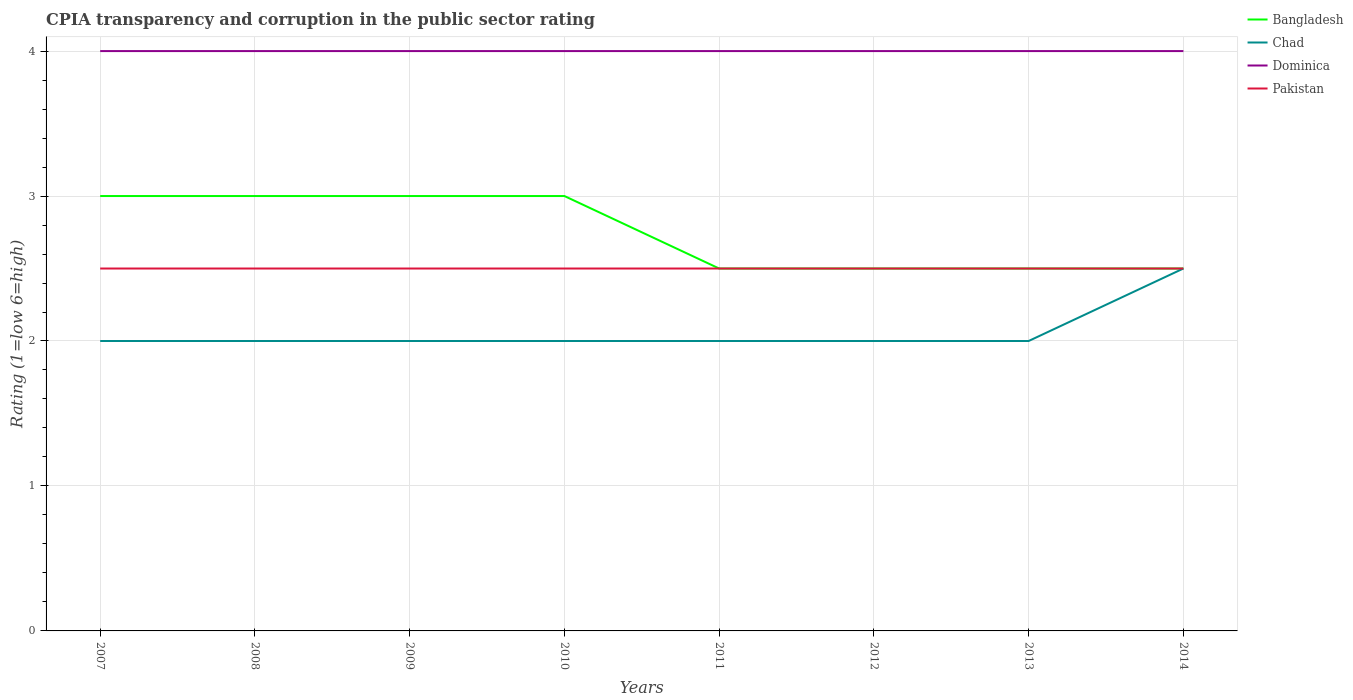How many different coloured lines are there?
Keep it short and to the point. 4. Does the line corresponding to Chad intersect with the line corresponding to Pakistan?
Make the answer very short. Yes. Across all years, what is the maximum CPIA rating in Dominica?
Your answer should be compact. 4. What is the difference between the highest and the lowest CPIA rating in Bangladesh?
Offer a very short reply. 4. Is the CPIA rating in Bangladesh strictly greater than the CPIA rating in Chad over the years?
Your answer should be very brief. No. How many years are there in the graph?
Give a very brief answer. 8. Does the graph contain any zero values?
Give a very brief answer. No. Where does the legend appear in the graph?
Provide a short and direct response. Top right. How many legend labels are there?
Keep it short and to the point. 4. How are the legend labels stacked?
Give a very brief answer. Vertical. What is the title of the graph?
Provide a short and direct response. CPIA transparency and corruption in the public sector rating. Does "Mauritania" appear as one of the legend labels in the graph?
Make the answer very short. No. What is the label or title of the X-axis?
Your response must be concise. Years. What is the label or title of the Y-axis?
Provide a succinct answer. Rating (1=low 6=high). What is the Rating (1=low 6=high) in Pakistan in 2007?
Provide a short and direct response. 2.5. What is the Rating (1=low 6=high) of Pakistan in 2008?
Your answer should be very brief. 2.5. What is the Rating (1=low 6=high) of Bangladesh in 2009?
Give a very brief answer. 3. What is the Rating (1=low 6=high) in Chad in 2009?
Keep it short and to the point. 2. What is the Rating (1=low 6=high) of Bangladesh in 2010?
Keep it short and to the point. 3. What is the Rating (1=low 6=high) in Chad in 2010?
Your answer should be compact. 2. What is the Rating (1=low 6=high) of Dominica in 2010?
Provide a short and direct response. 4. What is the Rating (1=low 6=high) of Pakistan in 2010?
Provide a succinct answer. 2.5. What is the Rating (1=low 6=high) of Chad in 2011?
Make the answer very short. 2. What is the Rating (1=low 6=high) of Dominica in 2011?
Make the answer very short. 4. What is the Rating (1=low 6=high) in Bangladesh in 2012?
Give a very brief answer. 2.5. What is the Rating (1=low 6=high) of Dominica in 2012?
Offer a terse response. 4. What is the Rating (1=low 6=high) in Pakistan in 2012?
Make the answer very short. 2.5. What is the Rating (1=low 6=high) in Bangladesh in 2013?
Your response must be concise. 2.5. What is the Rating (1=low 6=high) in Dominica in 2013?
Keep it short and to the point. 4. What is the Rating (1=low 6=high) in Pakistan in 2014?
Ensure brevity in your answer.  2.5. Across all years, what is the maximum Rating (1=low 6=high) of Bangladesh?
Ensure brevity in your answer.  3. Across all years, what is the maximum Rating (1=low 6=high) in Chad?
Offer a very short reply. 2.5. Across all years, what is the minimum Rating (1=low 6=high) of Bangladesh?
Provide a short and direct response. 2.5. Across all years, what is the minimum Rating (1=low 6=high) in Chad?
Your response must be concise. 2. Across all years, what is the minimum Rating (1=low 6=high) of Dominica?
Provide a short and direct response. 4. What is the total Rating (1=low 6=high) in Bangladesh in the graph?
Your response must be concise. 22. What is the total Rating (1=low 6=high) in Dominica in the graph?
Make the answer very short. 32. What is the difference between the Rating (1=low 6=high) in Chad in 2007 and that in 2008?
Give a very brief answer. 0. What is the difference between the Rating (1=low 6=high) of Dominica in 2007 and that in 2008?
Make the answer very short. 0. What is the difference between the Rating (1=low 6=high) in Pakistan in 2007 and that in 2008?
Offer a very short reply. 0. What is the difference between the Rating (1=low 6=high) in Chad in 2007 and that in 2009?
Ensure brevity in your answer.  0. What is the difference between the Rating (1=low 6=high) of Dominica in 2007 and that in 2009?
Give a very brief answer. 0. What is the difference between the Rating (1=low 6=high) in Pakistan in 2007 and that in 2009?
Keep it short and to the point. 0. What is the difference between the Rating (1=low 6=high) of Chad in 2007 and that in 2010?
Provide a succinct answer. 0. What is the difference between the Rating (1=low 6=high) of Pakistan in 2007 and that in 2010?
Provide a succinct answer. 0. What is the difference between the Rating (1=low 6=high) in Bangladesh in 2007 and that in 2011?
Ensure brevity in your answer.  0.5. What is the difference between the Rating (1=low 6=high) in Chad in 2007 and that in 2012?
Offer a terse response. 0. What is the difference between the Rating (1=low 6=high) of Pakistan in 2007 and that in 2012?
Your response must be concise. 0. What is the difference between the Rating (1=low 6=high) in Bangladesh in 2007 and that in 2013?
Give a very brief answer. 0.5. What is the difference between the Rating (1=low 6=high) in Dominica in 2007 and that in 2013?
Make the answer very short. 0. What is the difference between the Rating (1=low 6=high) of Bangladesh in 2007 and that in 2014?
Give a very brief answer. 0.5. What is the difference between the Rating (1=low 6=high) of Dominica in 2007 and that in 2014?
Your answer should be very brief. 0. What is the difference between the Rating (1=low 6=high) of Bangladesh in 2008 and that in 2009?
Keep it short and to the point. 0. What is the difference between the Rating (1=low 6=high) in Dominica in 2008 and that in 2009?
Ensure brevity in your answer.  0. What is the difference between the Rating (1=low 6=high) in Bangladesh in 2008 and that in 2010?
Provide a short and direct response. 0. What is the difference between the Rating (1=low 6=high) in Chad in 2008 and that in 2010?
Give a very brief answer. 0. What is the difference between the Rating (1=low 6=high) of Dominica in 2008 and that in 2010?
Provide a succinct answer. 0. What is the difference between the Rating (1=low 6=high) of Chad in 2008 and that in 2011?
Provide a succinct answer. 0. What is the difference between the Rating (1=low 6=high) of Pakistan in 2008 and that in 2011?
Ensure brevity in your answer.  0. What is the difference between the Rating (1=low 6=high) of Bangladesh in 2008 and that in 2012?
Your answer should be very brief. 0.5. What is the difference between the Rating (1=low 6=high) of Bangladesh in 2008 and that in 2013?
Provide a succinct answer. 0.5. What is the difference between the Rating (1=low 6=high) in Chad in 2008 and that in 2013?
Ensure brevity in your answer.  0. What is the difference between the Rating (1=low 6=high) in Dominica in 2008 and that in 2014?
Offer a very short reply. 0. What is the difference between the Rating (1=low 6=high) of Chad in 2009 and that in 2010?
Your answer should be compact. 0. What is the difference between the Rating (1=low 6=high) in Dominica in 2009 and that in 2010?
Your response must be concise. 0. What is the difference between the Rating (1=low 6=high) in Bangladesh in 2009 and that in 2011?
Your answer should be very brief. 0.5. What is the difference between the Rating (1=low 6=high) of Chad in 2009 and that in 2011?
Offer a terse response. 0. What is the difference between the Rating (1=low 6=high) in Bangladesh in 2009 and that in 2012?
Provide a short and direct response. 0.5. What is the difference between the Rating (1=low 6=high) in Chad in 2009 and that in 2012?
Provide a short and direct response. 0. What is the difference between the Rating (1=low 6=high) in Dominica in 2009 and that in 2012?
Offer a very short reply. 0. What is the difference between the Rating (1=low 6=high) of Pakistan in 2009 and that in 2012?
Give a very brief answer. 0. What is the difference between the Rating (1=low 6=high) of Bangladesh in 2009 and that in 2013?
Provide a succinct answer. 0.5. What is the difference between the Rating (1=low 6=high) in Chad in 2009 and that in 2013?
Ensure brevity in your answer.  0. What is the difference between the Rating (1=low 6=high) in Dominica in 2009 and that in 2013?
Keep it short and to the point. 0. What is the difference between the Rating (1=low 6=high) in Bangladesh in 2009 and that in 2014?
Ensure brevity in your answer.  0.5. What is the difference between the Rating (1=low 6=high) in Chad in 2009 and that in 2014?
Offer a terse response. -0.5. What is the difference between the Rating (1=low 6=high) of Dominica in 2010 and that in 2011?
Your answer should be very brief. 0. What is the difference between the Rating (1=low 6=high) in Pakistan in 2010 and that in 2011?
Keep it short and to the point. 0. What is the difference between the Rating (1=low 6=high) in Bangladesh in 2010 and that in 2012?
Offer a very short reply. 0.5. What is the difference between the Rating (1=low 6=high) of Chad in 2010 and that in 2012?
Give a very brief answer. 0. What is the difference between the Rating (1=low 6=high) of Pakistan in 2010 and that in 2012?
Provide a succinct answer. 0. What is the difference between the Rating (1=low 6=high) of Chad in 2010 and that in 2013?
Ensure brevity in your answer.  0. What is the difference between the Rating (1=low 6=high) in Dominica in 2010 and that in 2013?
Your answer should be very brief. 0. What is the difference between the Rating (1=low 6=high) in Pakistan in 2010 and that in 2013?
Ensure brevity in your answer.  0. What is the difference between the Rating (1=low 6=high) in Dominica in 2010 and that in 2014?
Give a very brief answer. 0. What is the difference between the Rating (1=low 6=high) in Pakistan in 2011 and that in 2012?
Your answer should be compact. 0. What is the difference between the Rating (1=low 6=high) of Bangladesh in 2011 and that in 2013?
Offer a very short reply. 0. What is the difference between the Rating (1=low 6=high) in Pakistan in 2011 and that in 2013?
Give a very brief answer. 0. What is the difference between the Rating (1=low 6=high) in Pakistan in 2011 and that in 2014?
Your answer should be very brief. 0. What is the difference between the Rating (1=low 6=high) of Bangladesh in 2012 and that in 2013?
Your answer should be compact. 0. What is the difference between the Rating (1=low 6=high) of Chad in 2012 and that in 2013?
Your response must be concise. 0. What is the difference between the Rating (1=low 6=high) of Dominica in 2012 and that in 2013?
Your answer should be compact. 0. What is the difference between the Rating (1=low 6=high) of Dominica in 2012 and that in 2014?
Make the answer very short. 0. What is the difference between the Rating (1=low 6=high) of Pakistan in 2012 and that in 2014?
Keep it short and to the point. 0. What is the difference between the Rating (1=low 6=high) in Bangladesh in 2013 and that in 2014?
Your response must be concise. 0. What is the difference between the Rating (1=low 6=high) in Pakistan in 2013 and that in 2014?
Your response must be concise. 0. What is the difference between the Rating (1=low 6=high) in Bangladesh in 2007 and the Rating (1=low 6=high) in Chad in 2008?
Provide a short and direct response. 1. What is the difference between the Rating (1=low 6=high) of Chad in 2007 and the Rating (1=low 6=high) of Dominica in 2008?
Offer a terse response. -2. What is the difference between the Rating (1=low 6=high) of Dominica in 2007 and the Rating (1=low 6=high) of Pakistan in 2008?
Offer a terse response. 1.5. What is the difference between the Rating (1=low 6=high) in Bangladesh in 2007 and the Rating (1=low 6=high) in Pakistan in 2009?
Provide a short and direct response. 0.5. What is the difference between the Rating (1=low 6=high) of Chad in 2007 and the Rating (1=low 6=high) of Dominica in 2009?
Give a very brief answer. -2. What is the difference between the Rating (1=low 6=high) of Chad in 2007 and the Rating (1=low 6=high) of Pakistan in 2009?
Keep it short and to the point. -0.5. What is the difference between the Rating (1=low 6=high) of Dominica in 2007 and the Rating (1=low 6=high) of Pakistan in 2009?
Offer a terse response. 1.5. What is the difference between the Rating (1=low 6=high) in Dominica in 2007 and the Rating (1=low 6=high) in Pakistan in 2010?
Provide a short and direct response. 1.5. What is the difference between the Rating (1=low 6=high) in Bangladesh in 2007 and the Rating (1=low 6=high) in Pakistan in 2011?
Your answer should be compact. 0.5. What is the difference between the Rating (1=low 6=high) of Chad in 2007 and the Rating (1=low 6=high) of Dominica in 2011?
Your answer should be compact. -2. What is the difference between the Rating (1=low 6=high) in Bangladesh in 2007 and the Rating (1=low 6=high) in Dominica in 2012?
Make the answer very short. -1. What is the difference between the Rating (1=low 6=high) of Bangladesh in 2007 and the Rating (1=low 6=high) of Pakistan in 2012?
Make the answer very short. 0.5. What is the difference between the Rating (1=low 6=high) in Chad in 2007 and the Rating (1=low 6=high) in Pakistan in 2012?
Your answer should be very brief. -0.5. What is the difference between the Rating (1=low 6=high) in Bangladesh in 2007 and the Rating (1=low 6=high) in Pakistan in 2013?
Offer a terse response. 0.5. What is the difference between the Rating (1=low 6=high) of Chad in 2007 and the Rating (1=low 6=high) of Pakistan in 2013?
Provide a short and direct response. -0.5. What is the difference between the Rating (1=low 6=high) in Bangladesh in 2007 and the Rating (1=low 6=high) in Chad in 2014?
Make the answer very short. 0.5. What is the difference between the Rating (1=low 6=high) in Bangladesh in 2007 and the Rating (1=low 6=high) in Dominica in 2014?
Offer a very short reply. -1. What is the difference between the Rating (1=low 6=high) in Bangladesh in 2007 and the Rating (1=low 6=high) in Pakistan in 2014?
Your answer should be compact. 0.5. What is the difference between the Rating (1=low 6=high) of Bangladesh in 2008 and the Rating (1=low 6=high) of Dominica in 2009?
Offer a very short reply. -1. What is the difference between the Rating (1=low 6=high) in Bangladesh in 2008 and the Rating (1=low 6=high) in Pakistan in 2009?
Your answer should be very brief. 0.5. What is the difference between the Rating (1=low 6=high) in Chad in 2008 and the Rating (1=low 6=high) in Pakistan in 2009?
Provide a succinct answer. -0.5. What is the difference between the Rating (1=low 6=high) in Bangladesh in 2008 and the Rating (1=low 6=high) in Dominica in 2010?
Your answer should be compact. -1. What is the difference between the Rating (1=low 6=high) in Chad in 2008 and the Rating (1=low 6=high) in Dominica in 2010?
Make the answer very short. -2. What is the difference between the Rating (1=low 6=high) of Chad in 2008 and the Rating (1=low 6=high) of Pakistan in 2010?
Your answer should be very brief. -0.5. What is the difference between the Rating (1=low 6=high) of Dominica in 2008 and the Rating (1=low 6=high) of Pakistan in 2010?
Make the answer very short. 1.5. What is the difference between the Rating (1=low 6=high) in Bangladesh in 2008 and the Rating (1=low 6=high) in Chad in 2011?
Offer a very short reply. 1. What is the difference between the Rating (1=low 6=high) in Bangladesh in 2008 and the Rating (1=low 6=high) in Dominica in 2011?
Your response must be concise. -1. What is the difference between the Rating (1=low 6=high) in Dominica in 2008 and the Rating (1=low 6=high) in Pakistan in 2011?
Provide a succinct answer. 1.5. What is the difference between the Rating (1=low 6=high) of Bangladesh in 2008 and the Rating (1=low 6=high) of Dominica in 2012?
Give a very brief answer. -1. What is the difference between the Rating (1=low 6=high) in Chad in 2008 and the Rating (1=low 6=high) in Pakistan in 2012?
Make the answer very short. -0.5. What is the difference between the Rating (1=low 6=high) of Dominica in 2008 and the Rating (1=low 6=high) of Pakistan in 2012?
Make the answer very short. 1.5. What is the difference between the Rating (1=low 6=high) of Bangladesh in 2008 and the Rating (1=low 6=high) of Chad in 2013?
Offer a terse response. 1. What is the difference between the Rating (1=low 6=high) of Bangladesh in 2008 and the Rating (1=low 6=high) of Chad in 2014?
Your response must be concise. 0.5. What is the difference between the Rating (1=low 6=high) in Bangladesh in 2008 and the Rating (1=low 6=high) in Dominica in 2014?
Your answer should be very brief. -1. What is the difference between the Rating (1=low 6=high) in Bangladesh in 2008 and the Rating (1=low 6=high) in Pakistan in 2014?
Provide a short and direct response. 0.5. What is the difference between the Rating (1=low 6=high) of Chad in 2008 and the Rating (1=low 6=high) of Dominica in 2014?
Your answer should be very brief. -2. What is the difference between the Rating (1=low 6=high) in Bangladesh in 2009 and the Rating (1=low 6=high) in Chad in 2012?
Ensure brevity in your answer.  1. What is the difference between the Rating (1=low 6=high) of Bangladesh in 2009 and the Rating (1=low 6=high) of Pakistan in 2012?
Your answer should be very brief. 0.5. What is the difference between the Rating (1=low 6=high) in Dominica in 2009 and the Rating (1=low 6=high) in Pakistan in 2012?
Your answer should be compact. 1.5. What is the difference between the Rating (1=low 6=high) of Bangladesh in 2009 and the Rating (1=low 6=high) of Chad in 2013?
Offer a terse response. 1. What is the difference between the Rating (1=low 6=high) in Bangladesh in 2009 and the Rating (1=low 6=high) in Dominica in 2013?
Give a very brief answer. -1. What is the difference between the Rating (1=low 6=high) in Bangladesh in 2009 and the Rating (1=low 6=high) in Pakistan in 2013?
Keep it short and to the point. 0.5. What is the difference between the Rating (1=low 6=high) of Chad in 2009 and the Rating (1=low 6=high) of Dominica in 2013?
Offer a very short reply. -2. What is the difference between the Rating (1=low 6=high) in Chad in 2009 and the Rating (1=low 6=high) in Pakistan in 2013?
Keep it short and to the point. -0.5. What is the difference between the Rating (1=low 6=high) of Dominica in 2009 and the Rating (1=low 6=high) of Pakistan in 2013?
Make the answer very short. 1.5. What is the difference between the Rating (1=low 6=high) of Bangladesh in 2009 and the Rating (1=low 6=high) of Chad in 2014?
Provide a succinct answer. 0.5. What is the difference between the Rating (1=low 6=high) of Bangladesh in 2009 and the Rating (1=low 6=high) of Dominica in 2014?
Ensure brevity in your answer.  -1. What is the difference between the Rating (1=low 6=high) in Bangladesh in 2009 and the Rating (1=low 6=high) in Pakistan in 2014?
Ensure brevity in your answer.  0.5. What is the difference between the Rating (1=low 6=high) in Chad in 2009 and the Rating (1=low 6=high) in Pakistan in 2014?
Your response must be concise. -0.5. What is the difference between the Rating (1=low 6=high) in Bangladesh in 2010 and the Rating (1=low 6=high) in Chad in 2011?
Ensure brevity in your answer.  1. What is the difference between the Rating (1=low 6=high) in Bangladesh in 2010 and the Rating (1=low 6=high) in Dominica in 2011?
Keep it short and to the point. -1. What is the difference between the Rating (1=low 6=high) of Bangladesh in 2010 and the Rating (1=low 6=high) of Pakistan in 2011?
Ensure brevity in your answer.  0.5. What is the difference between the Rating (1=low 6=high) in Chad in 2010 and the Rating (1=low 6=high) in Pakistan in 2011?
Your answer should be compact. -0.5. What is the difference between the Rating (1=low 6=high) of Bangladesh in 2010 and the Rating (1=low 6=high) of Pakistan in 2012?
Offer a very short reply. 0.5. What is the difference between the Rating (1=low 6=high) in Chad in 2010 and the Rating (1=low 6=high) in Dominica in 2012?
Ensure brevity in your answer.  -2. What is the difference between the Rating (1=low 6=high) of Dominica in 2010 and the Rating (1=low 6=high) of Pakistan in 2012?
Make the answer very short. 1.5. What is the difference between the Rating (1=low 6=high) in Bangladesh in 2010 and the Rating (1=low 6=high) in Chad in 2013?
Offer a terse response. 1. What is the difference between the Rating (1=low 6=high) of Bangladesh in 2010 and the Rating (1=low 6=high) of Dominica in 2013?
Provide a succinct answer. -1. What is the difference between the Rating (1=low 6=high) in Chad in 2010 and the Rating (1=low 6=high) in Dominica in 2013?
Provide a succinct answer. -2. What is the difference between the Rating (1=low 6=high) of Chad in 2010 and the Rating (1=low 6=high) of Pakistan in 2013?
Make the answer very short. -0.5. What is the difference between the Rating (1=low 6=high) in Dominica in 2010 and the Rating (1=low 6=high) in Pakistan in 2013?
Make the answer very short. 1.5. What is the difference between the Rating (1=low 6=high) in Bangladesh in 2010 and the Rating (1=low 6=high) in Chad in 2014?
Your response must be concise. 0.5. What is the difference between the Rating (1=low 6=high) of Bangladesh in 2010 and the Rating (1=low 6=high) of Pakistan in 2014?
Give a very brief answer. 0.5. What is the difference between the Rating (1=low 6=high) of Chad in 2010 and the Rating (1=low 6=high) of Dominica in 2014?
Give a very brief answer. -2. What is the difference between the Rating (1=low 6=high) of Bangladesh in 2011 and the Rating (1=low 6=high) of Chad in 2012?
Your response must be concise. 0.5. What is the difference between the Rating (1=low 6=high) in Bangladesh in 2011 and the Rating (1=low 6=high) in Dominica in 2012?
Your answer should be compact. -1.5. What is the difference between the Rating (1=low 6=high) in Chad in 2011 and the Rating (1=low 6=high) in Pakistan in 2012?
Ensure brevity in your answer.  -0.5. What is the difference between the Rating (1=low 6=high) in Bangladesh in 2011 and the Rating (1=low 6=high) in Dominica in 2013?
Make the answer very short. -1.5. What is the difference between the Rating (1=low 6=high) in Chad in 2011 and the Rating (1=low 6=high) in Pakistan in 2013?
Make the answer very short. -0.5. What is the difference between the Rating (1=low 6=high) in Bangladesh in 2011 and the Rating (1=low 6=high) in Chad in 2014?
Provide a succinct answer. 0. What is the difference between the Rating (1=low 6=high) in Bangladesh in 2011 and the Rating (1=low 6=high) in Dominica in 2014?
Your answer should be compact. -1.5. What is the difference between the Rating (1=low 6=high) of Bangladesh in 2011 and the Rating (1=low 6=high) of Pakistan in 2014?
Offer a very short reply. 0. What is the difference between the Rating (1=low 6=high) of Chad in 2011 and the Rating (1=low 6=high) of Pakistan in 2014?
Ensure brevity in your answer.  -0.5. What is the difference between the Rating (1=low 6=high) in Bangladesh in 2012 and the Rating (1=low 6=high) in Dominica in 2013?
Ensure brevity in your answer.  -1.5. What is the difference between the Rating (1=low 6=high) of Chad in 2012 and the Rating (1=low 6=high) of Dominica in 2013?
Provide a succinct answer. -2. What is the difference between the Rating (1=low 6=high) of Bangladesh in 2012 and the Rating (1=low 6=high) of Dominica in 2014?
Provide a short and direct response. -1.5. What is the difference between the Rating (1=low 6=high) of Chad in 2012 and the Rating (1=low 6=high) of Dominica in 2014?
Provide a succinct answer. -2. What is the difference between the Rating (1=low 6=high) of Chad in 2012 and the Rating (1=low 6=high) of Pakistan in 2014?
Provide a succinct answer. -0.5. What is the difference between the Rating (1=low 6=high) of Dominica in 2012 and the Rating (1=low 6=high) of Pakistan in 2014?
Offer a terse response. 1.5. What is the difference between the Rating (1=low 6=high) of Bangladesh in 2013 and the Rating (1=low 6=high) of Chad in 2014?
Your response must be concise. 0. What is the difference between the Rating (1=low 6=high) of Bangladesh in 2013 and the Rating (1=low 6=high) of Dominica in 2014?
Your response must be concise. -1.5. What is the difference between the Rating (1=low 6=high) in Chad in 2013 and the Rating (1=low 6=high) in Pakistan in 2014?
Make the answer very short. -0.5. What is the average Rating (1=low 6=high) of Bangladesh per year?
Make the answer very short. 2.75. What is the average Rating (1=low 6=high) in Chad per year?
Make the answer very short. 2.06. What is the average Rating (1=low 6=high) of Dominica per year?
Keep it short and to the point. 4. What is the average Rating (1=low 6=high) of Pakistan per year?
Your response must be concise. 2.5. In the year 2007, what is the difference between the Rating (1=low 6=high) of Bangladesh and Rating (1=low 6=high) of Chad?
Keep it short and to the point. 1. In the year 2007, what is the difference between the Rating (1=low 6=high) of Chad and Rating (1=low 6=high) of Pakistan?
Offer a terse response. -0.5. In the year 2007, what is the difference between the Rating (1=low 6=high) of Dominica and Rating (1=low 6=high) of Pakistan?
Keep it short and to the point. 1.5. In the year 2008, what is the difference between the Rating (1=low 6=high) of Bangladesh and Rating (1=low 6=high) of Chad?
Ensure brevity in your answer.  1. In the year 2008, what is the difference between the Rating (1=low 6=high) of Chad and Rating (1=low 6=high) of Dominica?
Offer a terse response. -2. In the year 2008, what is the difference between the Rating (1=low 6=high) of Chad and Rating (1=low 6=high) of Pakistan?
Keep it short and to the point. -0.5. In the year 2008, what is the difference between the Rating (1=low 6=high) of Dominica and Rating (1=low 6=high) of Pakistan?
Give a very brief answer. 1.5. In the year 2009, what is the difference between the Rating (1=low 6=high) in Bangladesh and Rating (1=low 6=high) in Chad?
Your answer should be very brief. 1. In the year 2009, what is the difference between the Rating (1=low 6=high) of Chad and Rating (1=low 6=high) of Dominica?
Provide a succinct answer. -2. In the year 2009, what is the difference between the Rating (1=low 6=high) in Dominica and Rating (1=low 6=high) in Pakistan?
Keep it short and to the point. 1.5. In the year 2010, what is the difference between the Rating (1=low 6=high) in Bangladesh and Rating (1=low 6=high) in Dominica?
Provide a succinct answer. -1. In the year 2011, what is the difference between the Rating (1=low 6=high) of Bangladesh and Rating (1=low 6=high) of Dominica?
Keep it short and to the point. -1.5. In the year 2011, what is the difference between the Rating (1=low 6=high) of Bangladesh and Rating (1=low 6=high) of Pakistan?
Provide a succinct answer. 0. In the year 2011, what is the difference between the Rating (1=low 6=high) in Chad and Rating (1=low 6=high) in Dominica?
Provide a succinct answer. -2. In the year 2012, what is the difference between the Rating (1=low 6=high) in Bangladesh and Rating (1=low 6=high) in Dominica?
Give a very brief answer. -1.5. In the year 2012, what is the difference between the Rating (1=low 6=high) of Chad and Rating (1=low 6=high) of Dominica?
Your answer should be compact. -2. In the year 2012, what is the difference between the Rating (1=low 6=high) of Chad and Rating (1=low 6=high) of Pakistan?
Keep it short and to the point. -0.5. In the year 2012, what is the difference between the Rating (1=low 6=high) of Dominica and Rating (1=low 6=high) of Pakistan?
Your response must be concise. 1.5. In the year 2013, what is the difference between the Rating (1=low 6=high) of Bangladesh and Rating (1=low 6=high) of Dominica?
Provide a succinct answer. -1.5. In the year 2013, what is the difference between the Rating (1=low 6=high) of Bangladesh and Rating (1=low 6=high) of Pakistan?
Offer a terse response. 0. In the year 2013, what is the difference between the Rating (1=low 6=high) of Chad and Rating (1=low 6=high) of Dominica?
Your answer should be very brief. -2. In the year 2013, what is the difference between the Rating (1=low 6=high) in Chad and Rating (1=low 6=high) in Pakistan?
Your answer should be compact. -0.5. In the year 2013, what is the difference between the Rating (1=low 6=high) of Dominica and Rating (1=low 6=high) of Pakistan?
Provide a short and direct response. 1.5. In the year 2014, what is the difference between the Rating (1=low 6=high) of Bangladesh and Rating (1=low 6=high) of Pakistan?
Your response must be concise. 0. In the year 2014, what is the difference between the Rating (1=low 6=high) in Chad and Rating (1=low 6=high) in Pakistan?
Give a very brief answer. 0. In the year 2014, what is the difference between the Rating (1=low 6=high) of Dominica and Rating (1=low 6=high) of Pakistan?
Give a very brief answer. 1.5. What is the ratio of the Rating (1=low 6=high) of Bangladesh in 2007 to that in 2008?
Provide a short and direct response. 1. What is the ratio of the Rating (1=low 6=high) in Chad in 2007 to that in 2008?
Your response must be concise. 1. What is the ratio of the Rating (1=low 6=high) in Dominica in 2007 to that in 2008?
Make the answer very short. 1. What is the ratio of the Rating (1=low 6=high) of Bangladesh in 2007 to that in 2009?
Give a very brief answer. 1. What is the ratio of the Rating (1=low 6=high) of Dominica in 2007 to that in 2009?
Offer a very short reply. 1. What is the ratio of the Rating (1=low 6=high) in Pakistan in 2007 to that in 2009?
Your answer should be very brief. 1. What is the ratio of the Rating (1=low 6=high) in Chad in 2007 to that in 2010?
Provide a succinct answer. 1. What is the ratio of the Rating (1=low 6=high) in Dominica in 2007 to that in 2010?
Offer a very short reply. 1. What is the ratio of the Rating (1=low 6=high) of Bangladesh in 2007 to that in 2011?
Offer a terse response. 1.2. What is the ratio of the Rating (1=low 6=high) of Chad in 2007 to that in 2011?
Give a very brief answer. 1. What is the ratio of the Rating (1=low 6=high) of Dominica in 2007 to that in 2011?
Provide a succinct answer. 1. What is the ratio of the Rating (1=low 6=high) of Pakistan in 2007 to that in 2011?
Give a very brief answer. 1. What is the ratio of the Rating (1=low 6=high) of Bangladesh in 2007 to that in 2012?
Your answer should be very brief. 1.2. What is the ratio of the Rating (1=low 6=high) of Dominica in 2007 to that in 2012?
Your answer should be compact. 1. What is the ratio of the Rating (1=low 6=high) of Chad in 2007 to that in 2013?
Your response must be concise. 1. What is the ratio of the Rating (1=low 6=high) in Pakistan in 2007 to that in 2013?
Offer a terse response. 1. What is the ratio of the Rating (1=low 6=high) in Bangladesh in 2007 to that in 2014?
Give a very brief answer. 1.2. What is the ratio of the Rating (1=low 6=high) in Dominica in 2007 to that in 2014?
Offer a very short reply. 1. What is the ratio of the Rating (1=low 6=high) of Pakistan in 2007 to that in 2014?
Offer a very short reply. 1. What is the ratio of the Rating (1=low 6=high) in Bangladesh in 2008 to that in 2009?
Make the answer very short. 1. What is the ratio of the Rating (1=low 6=high) in Dominica in 2008 to that in 2009?
Ensure brevity in your answer.  1. What is the ratio of the Rating (1=low 6=high) in Pakistan in 2008 to that in 2009?
Ensure brevity in your answer.  1. What is the ratio of the Rating (1=low 6=high) of Bangladesh in 2008 to that in 2010?
Offer a very short reply. 1. What is the ratio of the Rating (1=low 6=high) of Dominica in 2008 to that in 2010?
Keep it short and to the point. 1. What is the ratio of the Rating (1=low 6=high) of Pakistan in 2008 to that in 2010?
Your answer should be very brief. 1. What is the ratio of the Rating (1=low 6=high) in Chad in 2008 to that in 2011?
Your answer should be very brief. 1. What is the ratio of the Rating (1=low 6=high) in Bangladesh in 2008 to that in 2012?
Give a very brief answer. 1.2. What is the ratio of the Rating (1=low 6=high) of Pakistan in 2008 to that in 2012?
Offer a terse response. 1. What is the ratio of the Rating (1=low 6=high) of Chad in 2008 to that in 2013?
Offer a terse response. 1. What is the ratio of the Rating (1=low 6=high) of Bangladesh in 2008 to that in 2014?
Offer a very short reply. 1.2. What is the ratio of the Rating (1=low 6=high) in Pakistan in 2008 to that in 2014?
Ensure brevity in your answer.  1. What is the ratio of the Rating (1=low 6=high) in Dominica in 2009 to that in 2010?
Give a very brief answer. 1. What is the ratio of the Rating (1=low 6=high) of Pakistan in 2009 to that in 2010?
Ensure brevity in your answer.  1. What is the ratio of the Rating (1=low 6=high) of Bangladesh in 2009 to that in 2012?
Your response must be concise. 1.2. What is the ratio of the Rating (1=low 6=high) of Chad in 2009 to that in 2012?
Provide a succinct answer. 1. What is the ratio of the Rating (1=low 6=high) of Bangladesh in 2009 to that in 2013?
Provide a succinct answer. 1.2. What is the ratio of the Rating (1=low 6=high) of Dominica in 2009 to that in 2013?
Ensure brevity in your answer.  1. What is the ratio of the Rating (1=low 6=high) in Bangladesh in 2009 to that in 2014?
Offer a very short reply. 1.2. What is the ratio of the Rating (1=low 6=high) in Chad in 2009 to that in 2014?
Provide a short and direct response. 0.8. What is the ratio of the Rating (1=low 6=high) in Pakistan in 2009 to that in 2014?
Your answer should be compact. 1. What is the ratio of the Rating (1=low 6=high) in Pakistan in 2010 to that in 2011?
Keep it short and to the point. 1. What is the ratio of the Rating (1=low 6=high) in Chad in 2010 to that in 2012?
Your answer should be very brief. 1. What is the ratio of the Rating (1=low 6=high) of Bangladesh in 2010 to that in 2013?
Provide a short and direct response. 1.2. What is the ratio of the Rating (1=low 6=high) of Dominica in 2010 to that in 2013?
Offer a very short reply. 1. What is the ratio of the Rating (1=low 6=high) of Pakistan in 2010 to that in 2013?
Give a very brief answer. 1. What is the ratio of the Rating (1=low 6=high) in Bangladesh in 2010 to that in 2014?
Ensure brevity in your answer.  1.2. What is the ratio of the Rating (1=low 6=high) of Chad in 2010 to that in 2014?
Your answer should be very brief. 0.8. What is the ratio of the Rating (1=low 6=high) of Bangladesh in 2011 to that in 2012?
Give a very brief answer. 1. What is the ratio of the Rating (1=low 6=high) in Chad in 2011 to that in 2012?
Provide a succinct answer. 1. What is the ratio of the Rating (1=low 6=high) of Bangladesh in 2011 to that in 2013?
Give a very brief answer. 1. What is the ratio of the Rating (1=low 6=high) in Dominica in 2011 to that in 2013?
Give a very brief answer. 1. What is the ratio of the Rating (1=low 6=high) in Bangladesh in 2011 to that in 2014?
Ensure brevity in your answer.  1. What is the ratio of the Rating (1=low 6=high) in Chad in 2011 to that in 2014?
Ensure brevity in your answer.  0.8. What is the ratio of the Rating (1=low 6=high) of Dominica in 2011 to that in 2014?
Keep it short and to the point. 1. What is the ratio of the Rating (1=low 6=high) in Chad in 2012 to that in 2013?
Provide a short and direct response. 1. What is the ratio of the Rating (1=low 6=high) of Bangladesh in 2012 to that in 2014?
Keep it short and to the point. 1. What is the ratio of the Rating (1=low 6=high) in Chad in 2012 to that in 2014?
Ensure brevity in your answer.  0.8. What is the ratio of the Rating (1=low 6=high) of Bangladesh in 2013 to that in 2014?
Provide a succinct answer. 1. What is the ratio of the Rating (1=low 6=high) in Dominica in 2013 to that in 2014?
Your answer should be compact. 1. What is the ratio of the Rating (1=low 6=high) in Pakistan in 2013 to that in 2014?
Provide a short and direct response. 1. What is the difference between the highest and the second highest Rating (1=low 6=high) in Bangladesh?
Make the answer very short. 0. What is the difference between the highest and the second highest Rating (1=low 6=high) of Chad?
Keep it short and to the point. 0.5. What is the difference between the highest and the second highest Rating (1=low 6=high) in Dominica?
Give a very brief answer. 0. What is the difference between the highest and the second highest Rating (1=low 6=high) in Pakistan?
Give a very brief answer. 0. What is the difference between the highest and the lowest Rating (1=low 6=high) of Bangladesh?
Your response must be concise. 0.5. What is the difference between the highest and the lowest Rating (1=low 6=high) in Dominica?
Provide a short and direct response. 0. 